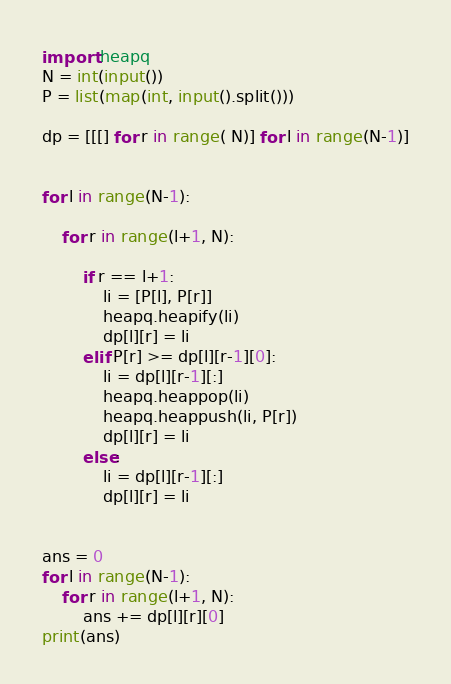Convert code to text. <code><loc_0><loc_0><loc_500><loc_500><_Python_>import heapq
N = int(input())
P = list(map(int, input().split()))

dp = [[[] for r in range( N)] for l in range(N-1)]


for l in range(N-1):

    for r in range(l+1, N):

        if r == l+1:
            li = [P[l], P[r]]
            heapq.heapify(li)
            dp[l][r] = li
        elif P[r] >= dp[l][r-1][0]:
            li = dp[l][r-1][:]
            heapq.heappop(li)
            heapq.heappush(li, P[r])
            dp[l][r] = li
        else:
            li = dp[l][r-1][:]
            dp[l][r] = li


ans = 0
for l in range(N-1):
    for r in range(l+1, N):
        ans += dp[l][r][0]
print(ans)</code> 